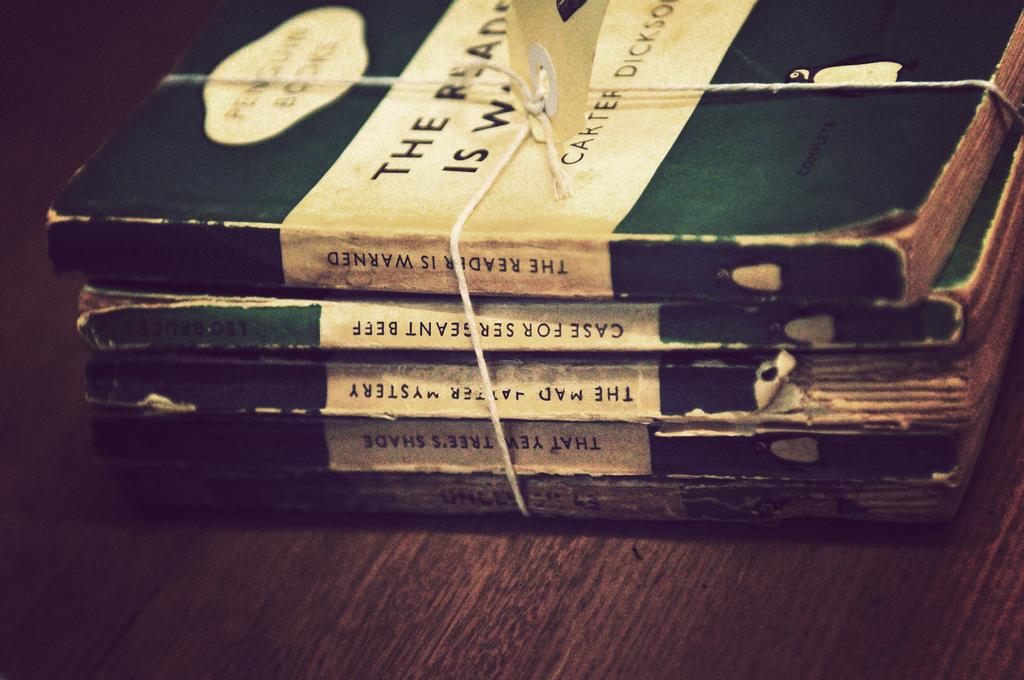<image>
Create a compact narrative representing the image presented. a stack of five books where one says 'the reader is warden' on the side o it 